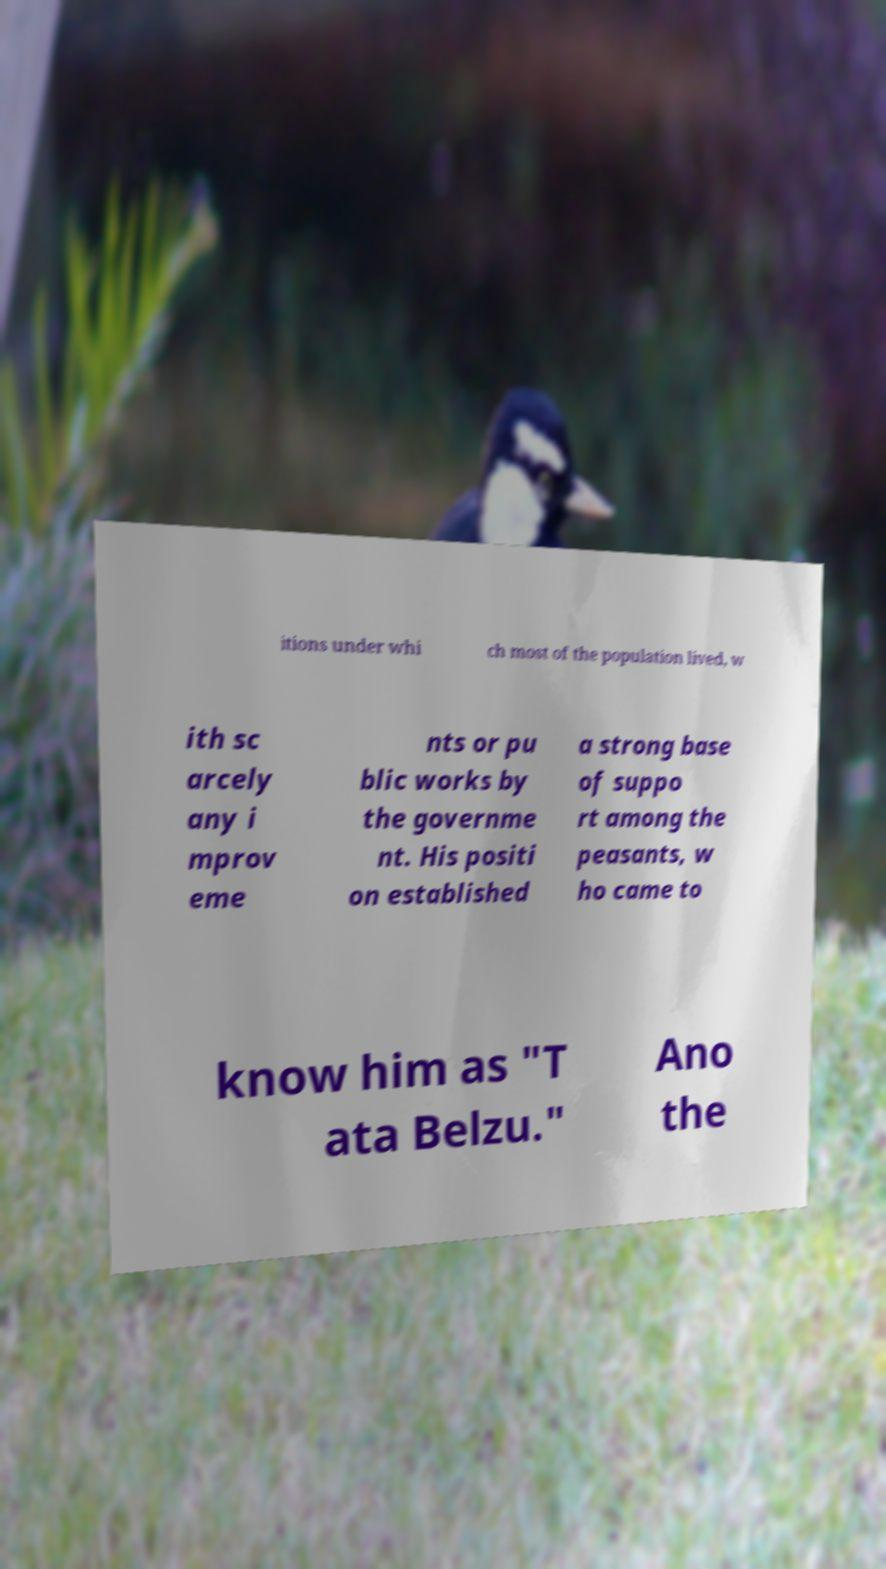There's text embedded in this image that I need extracted. Can you transcribe it verbatim? itions under whi ch most of the population lived, w ith sc arcely any i mprov eme nts or pu blic works by the governme nt. His positi on established a strong base of suppo rt among the peasants, w ho came to know him as "T ata Belzu." Ano the 